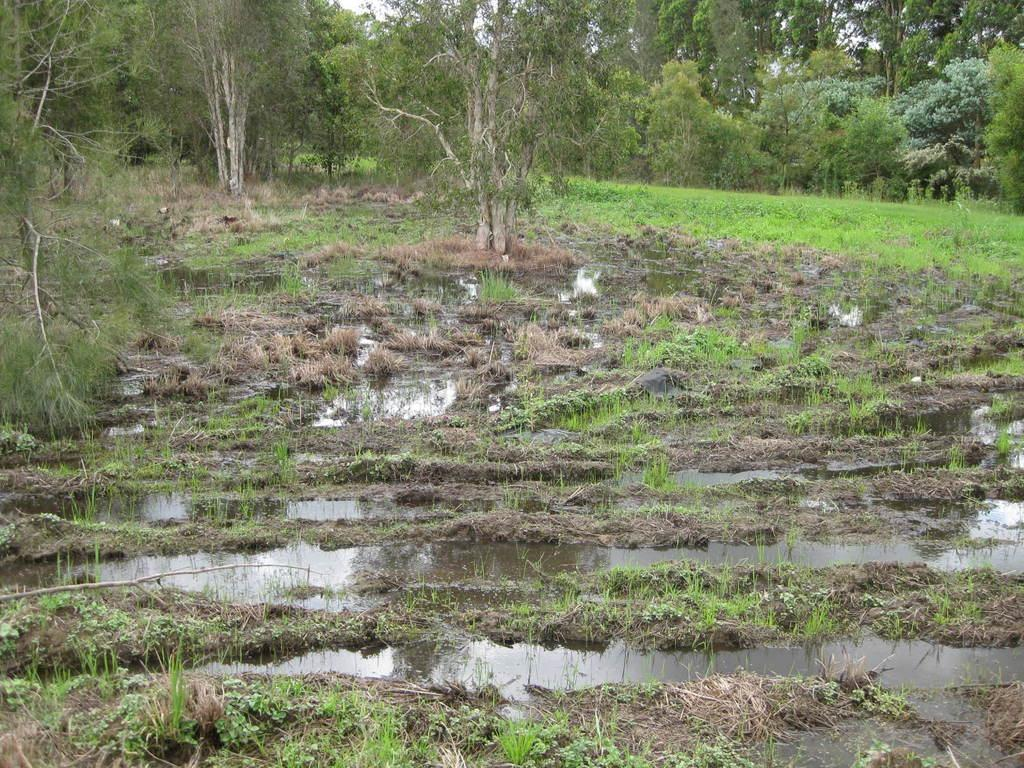What type of natural environment is depicted in the image? The image features water, grass, trees, and the sky, indicating a natural environment. Can you describe the water in the image? The water is visible in the image, but its specific characteristics are not mentioned in the provided facts. What type of vegetation is present in the image? There is grass and trees visible in the image. What is visible in the background of the image? The sky is visible in the image. How many beads are scattered on the grass in the image? There is no mention of beads in the provided facts, so we cannot determine if any are present in the image. What type of garden can be seen in the image? The provided facts do not mention a garden, so we cannot determine if one is present in the image. 